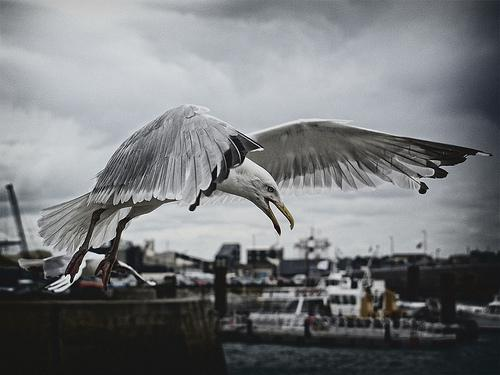Question: when was this taken?
Choices:
A. Nighttime.
B. Morning.
C. Daytime.
D. Evening.
Answer with the letter. Answer: C Question: what animal is shown?
Choices:
A. Camel.
B. Bird.
C. Dog.
D. Cat.
Answer with the letter. Answer: B Question: what color are the birds wings?
Choices:
A. White.
B. Blue.
C. Brown.
D. Grey.
Answer with the letter. Answer: A Question: how many people are in the shot?
Choices:
A. 2.
B. 3.
C. 4.
D. 0.
Answer with the letter. Answer: D 